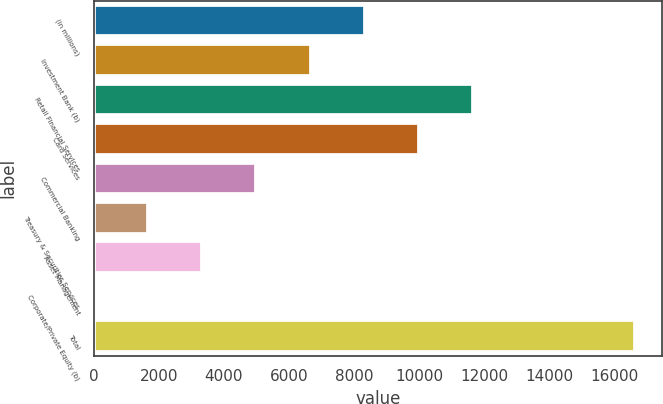Convert chart. <chart><loc_0><loc_0><loc_500><loc_500><bar_chart><fcel>(in millions)<fcel>Investment Bank (b)<fcel>Retail Financial Services<fcel>Card Services<fcel>Commercial Banking<fcel>Treasury & Securities Services<fcel>Asset Management<fcel>Corporate/Private Equity (b)<fcel>Total<nl><fcel>8326.5<fcel>6664<fcel>11651.5<fcel>9989<fcel>5001.5<fcel>1676.5<fcel>3339<fcel>14<fcel>16639<nl></chart> 